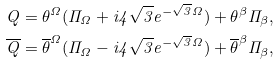Convert formula to latex. <formula><loc_0><loc_0><loc_500><loc_500>Q = \theta ^ { \Omega } ( \Pi _ { \Omega } + i 4 \sqrt { 3 } e ^ { - \sqrt { 3 } \Omega } ) + \theta ^ { \beta } \Pi _ { \beta } , \\ \overline { Q } = \overline { \theta } ^ { \Omega } ( \Pi _ { \Omega } - i 4 \sqrt { 3 } e ^ { - \sqrt { 3 } \Omega } ) + \overline { \theta } ^ { \beta } \Pi _ { \beta } ,</formula> 